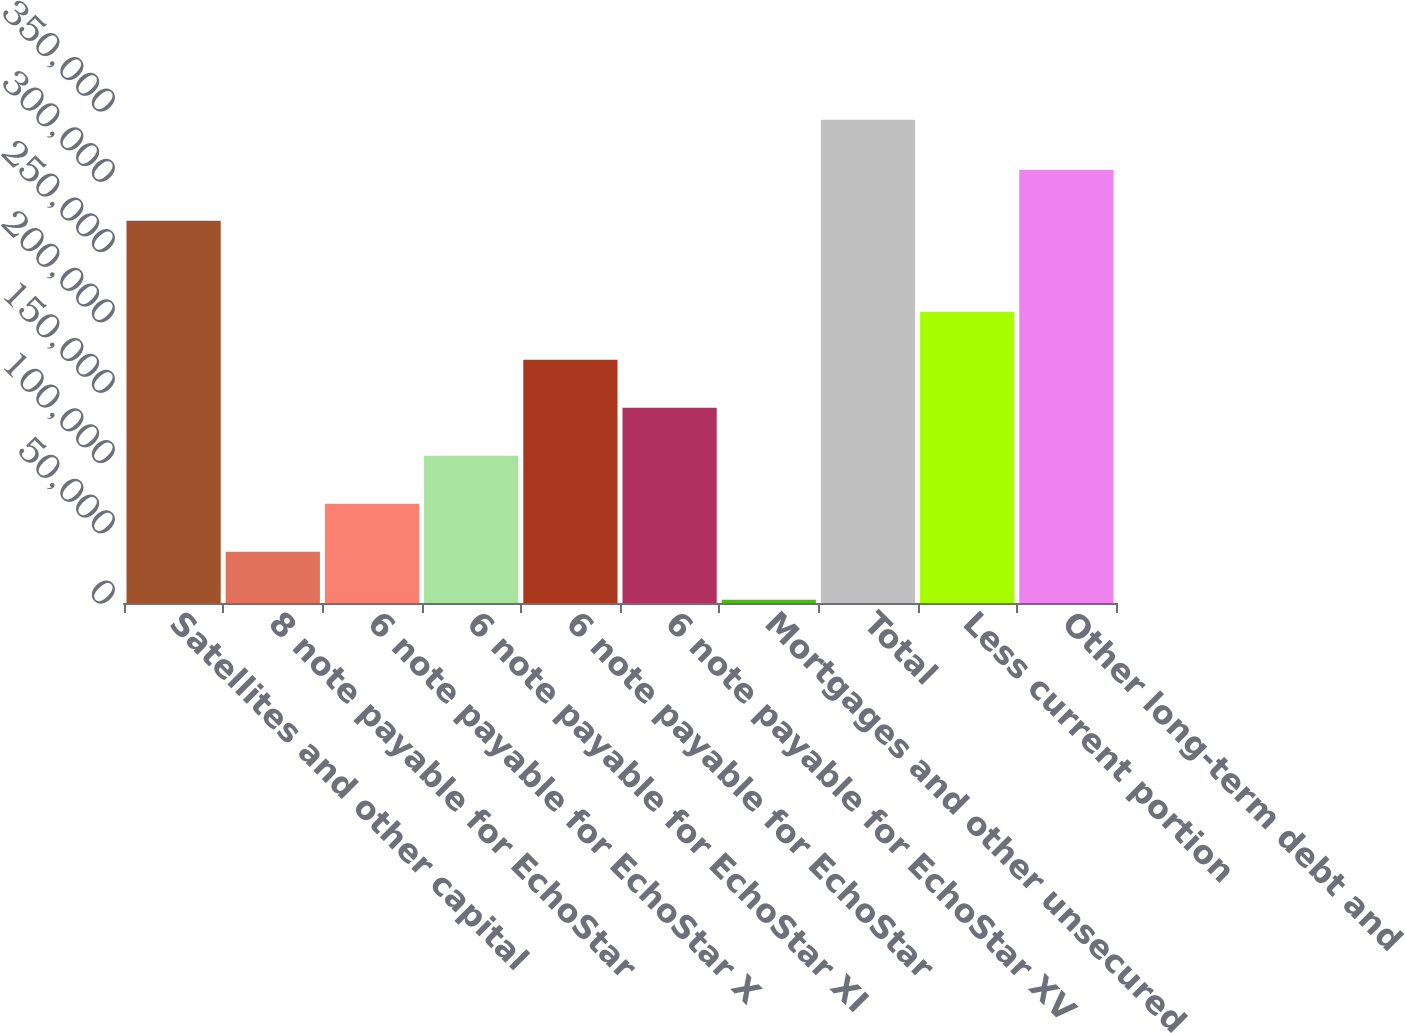Convert chart. <chart><loc_0><loc_0><loc_500><loc_500><bar_chart><fcel>Satellites and other capital<fcel>8 note payable for EchoStar<fcel>6 note payable for EchoStar X<fcel>6 note payable for EchoStar XI<fcel>6 note payable for EchoStar<fcel>6 note payable for EchoStar XV<fcel>Mortgages and other unsecured<fcel>Total<fcel>Less current portion<fcel>Other long-term debt and<nl><fcel>271908<fcel>36384<fcel>70539<fcel>104694<fcel>173004<fcel>138849<fcel>2229<fcel>343779<fcel>207159<fcel>308134<nl></chart> 